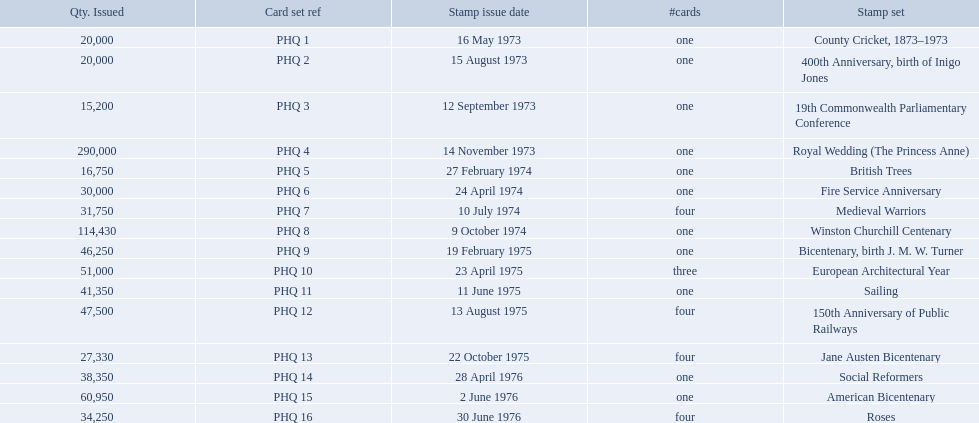What are all of the stamp sets? County Cricket, 1873–1973, 400th Anniversary, birth of Inigo Jones, 19th Commonwealth Parliamentary Conference, Royal Wedding (The Princess Anne), British Trees, Fire Service Anniversary, Medieval Warriors, Winston Churchill Centenary, Bicentenary, birth J. M. W. Turner, European Architectural Year, Sailing, 150th Anniversary of Public Railways, Jane Austen Bicentenary, Social Reformers, American Bicentenary, Roses. Which of these sets has three cards in it? European Architectural Year. 